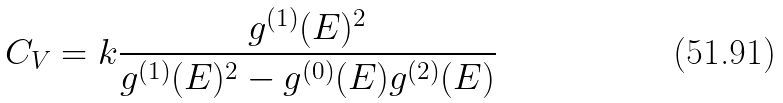Convert formula to latex. <formula><loc_0><loc_0><loc_500><loc_500>C _ { V } = k \frac { g ^ { ( 1 ) } ( E ) ^ { 2 } } { g ^ { ( 1 ) } ( E ) ^ { 2 } - g ^ { ( 0 ) } ( E ) g ^ { ( 2 ) } ( E ) }</formula> 